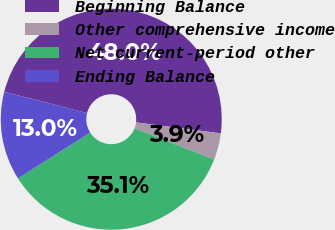Convert chart to OTSL. <chart><loc_0><loc_0><loc_500><loc_500><pie_chart><fcel>Beginning Balance<fcel>Other comprehensive income<fcel>Net current-period other<fcel>Ending Balance<nl><fcel>48.05%<fcel>3.9%<fcel>35.06%<fcel>12.99%<nl></chart> 